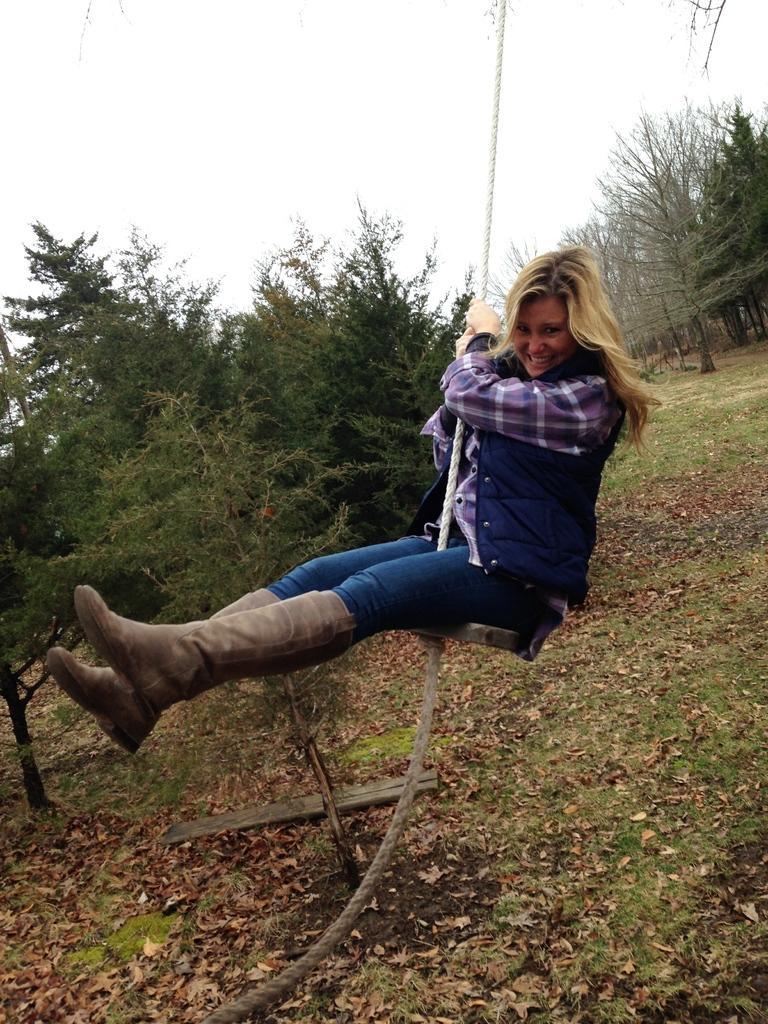Please provide a concise description of this image. In this image, we can see a person holding a rope. We can see some trees and the sky. We can also see the ground with grass, dried leaves and a wooden object. We can also see the sky. 